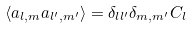<formula> <loc_0><loc_0><loc_500><loc_500>\langle a _ { l , m } a _ { l ^ { \prime } , m ^ { \prime } } \rangle = \delta _ { l l ^ { \prime } } \delta _ { m , m ^ { \prime } } C _ { l }</formula> 